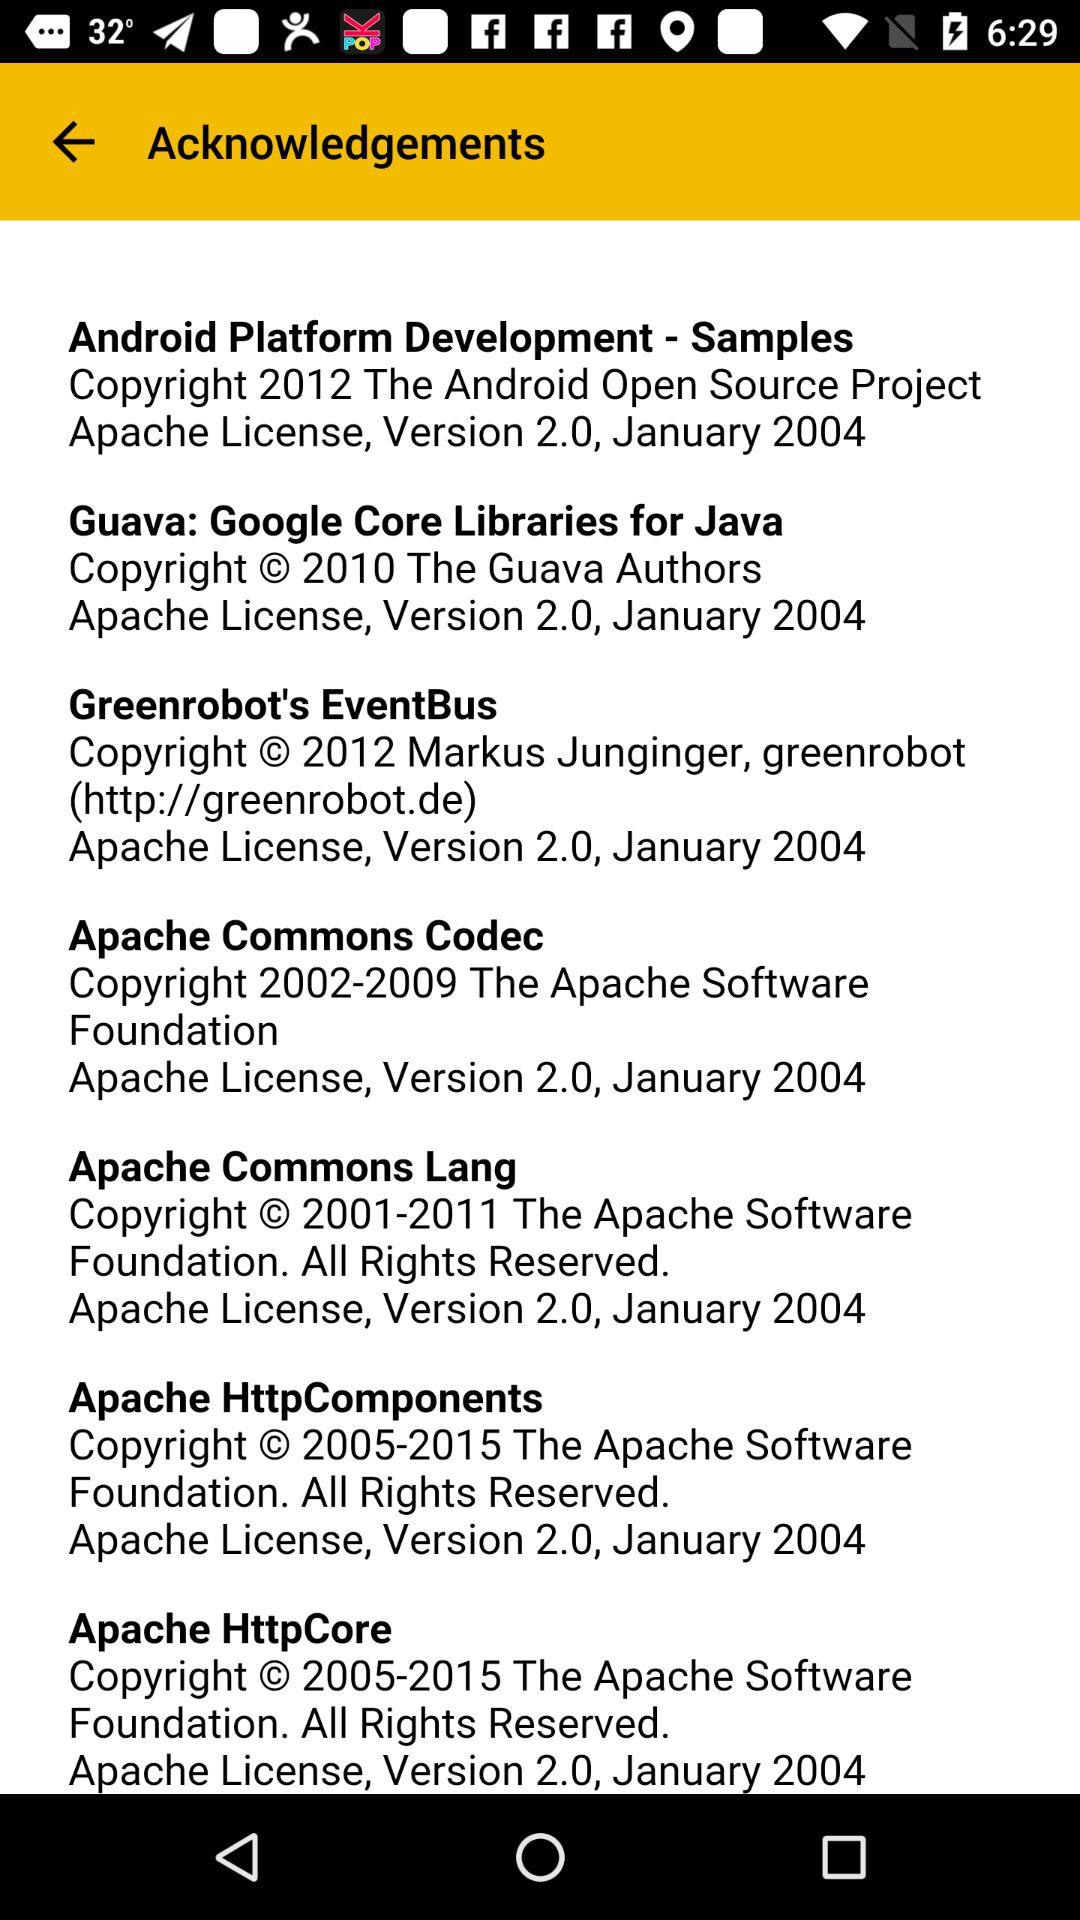How many Apache projects are used by the Android Platform Development Samples?
Answer the question using a single word or phrase. 7 